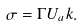Convert formula to latex. <formula><loc_0><loc_0><loc_500><loc_500>\sigma = \Gamma U _ { a } k .</formula> 